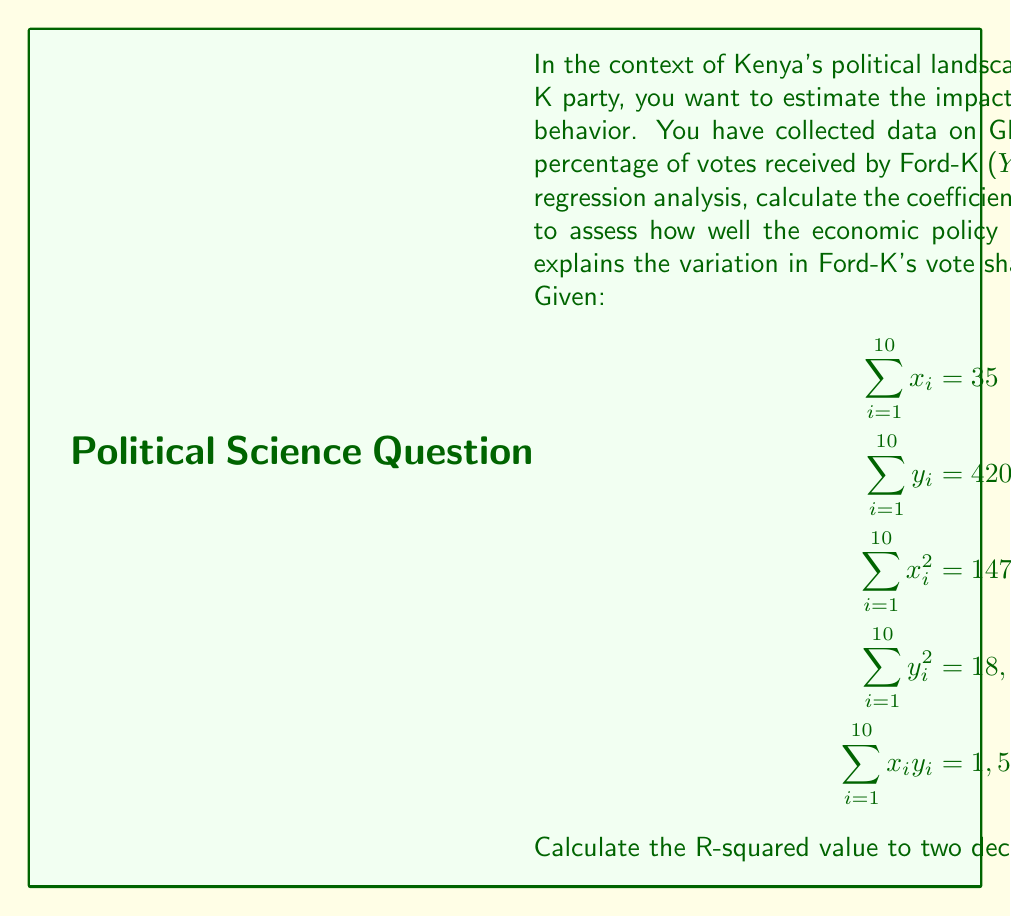Show me your answer to this math problem. To calculate the R-squared value, we need to follow these steps:

1. Calculate the means of X and Y:
   $$\bar{x} = \frac{\sum x_i}{n} = \frac{35}{10} = 3.5$$
   $$\bar{y} = \frac{\sum y_i}{n} = \frac{420}{10} = 42$$

2. Calculate the slope (b) of the regression line:
   $$b = \frac{n\sum x_iy_i - \sum x_i \sum y_i}{n\sum x_i^2 - (\sum x_i)^2}$$
   $$b = \frac{10(1,575) - 35(420)}{10(147.5) - 35^2} = \frac{15,750 - 14,700}{1,475 - 1,225} = \frac{1,050}{250} = 4.2$$

3. Calculate the y-intercept (a) of the regression line:
   $$a = \bar{y} - b\bar{x} = 42 - 4.2(3.5) = 27.3$$

4. Calculate the total sum of squares (SST):
   $$SST = \sum y_i^2 - n\bar{y}^2 = 18,600 - 10(42^2) = 18,600 - 17,640 = 960$$

5. Calculate the regression sum of squares (SSR):
   $$SSR = b(\sum x_iy_i - n\bar{x}\bar{y})$$
   $$SSR = 4.2(1,575 - 10(3.5)(42)) = 4.2(1,575 - 1,470) = 4.2(105) = 441$$

6. Calculate R-squared:
   $$R^2 = \frac{SSR}{SST} = \frac{441}{960} = 0.45937$$

Rounding to two decimal places, we get R-squared = 0.46.
Answer: R-squared = 0.46 